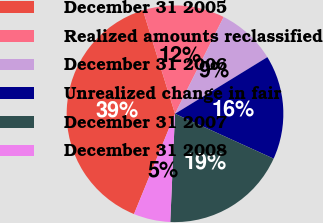Convert chart to OTSL. <chart><loc_0><loc_0><loc_500><loc_500><pie_chart><fcel>December 31 2005<fcel>Realized amounts reclassified<fcel>December 31 2006<fcel>Unrealized change in fair<fcel>December 31 2007<fcel>December 31 2008<nl><fcel>39.04%<fcel>12.19%<fcel>8.83%<fcel>15.55%<fcel>18.9%<fcel>5.48%<nl></chart> 